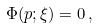<formula> <loc_0><loc_0><loc_500><loc_500>\Phi ( p ; \xi ) = 0 \, ,</formula> 